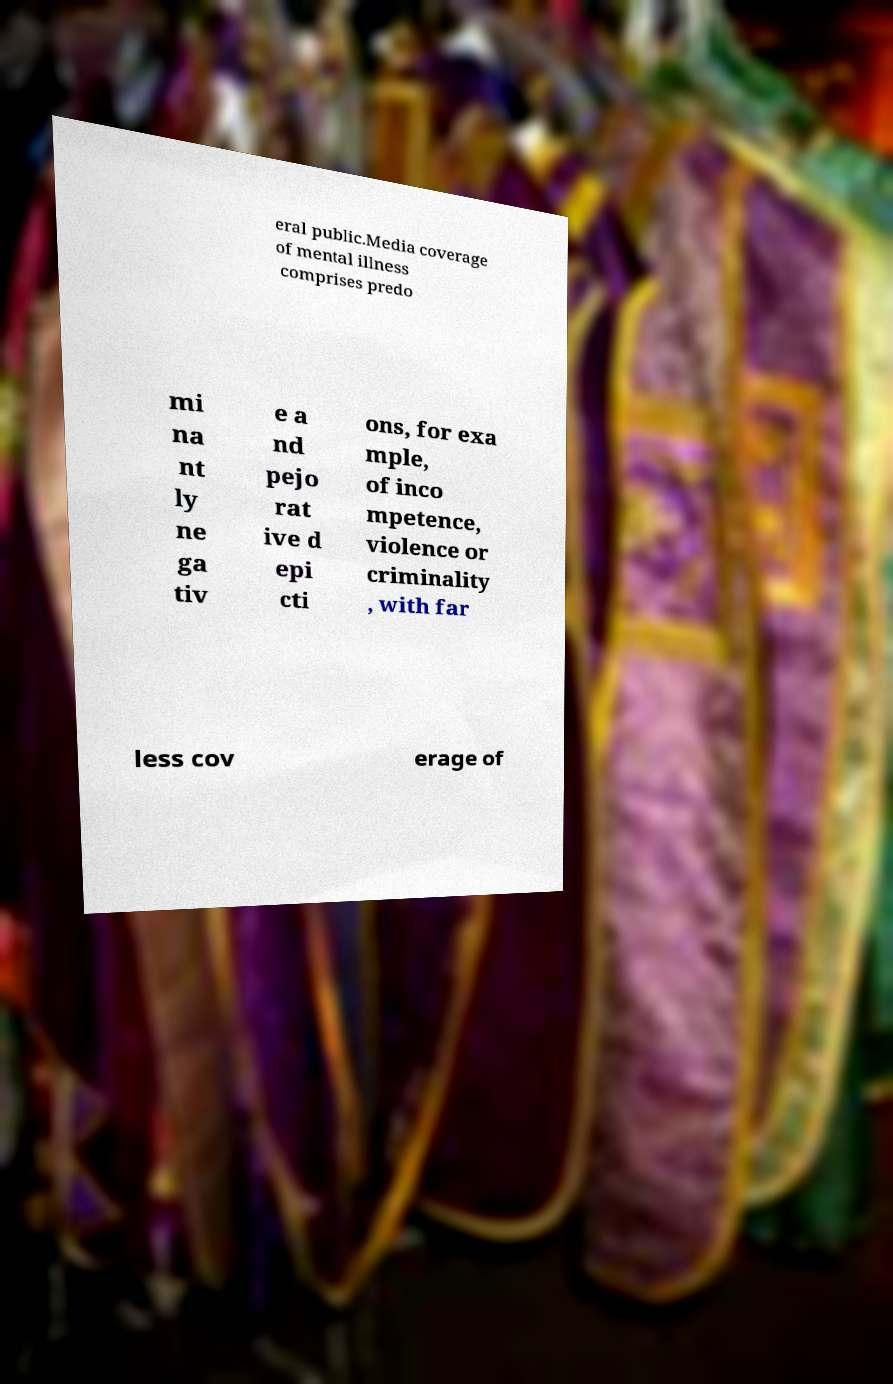Please read and relay the text visible in this image. What does it say? eral public.Media coverage of mental illness comprises predo mi na nt ly ne ga tiv e a nd pejo rat ive d epi cti ons, for exa mple, of inco mpetence, violence or criminality , with far less cov erage of 